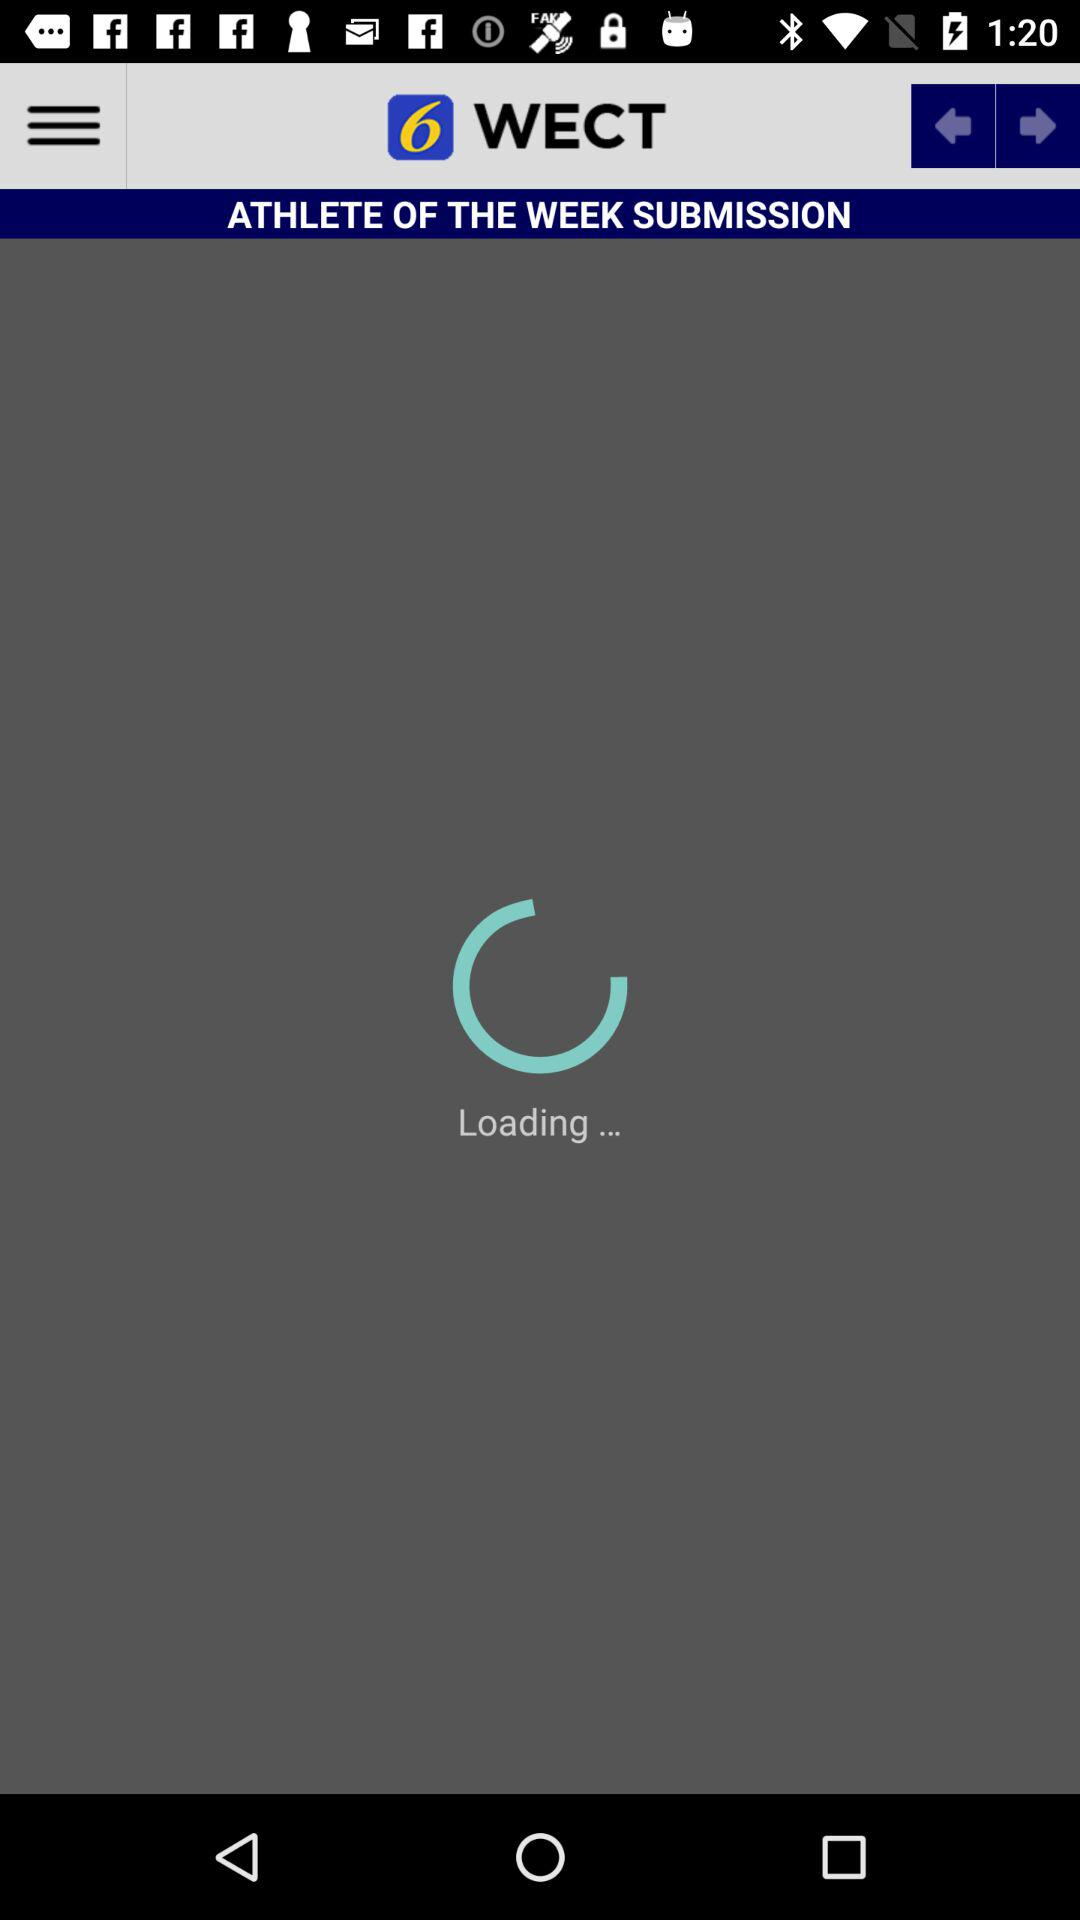What is the application name? The application name is "WECT 6 Local News". 